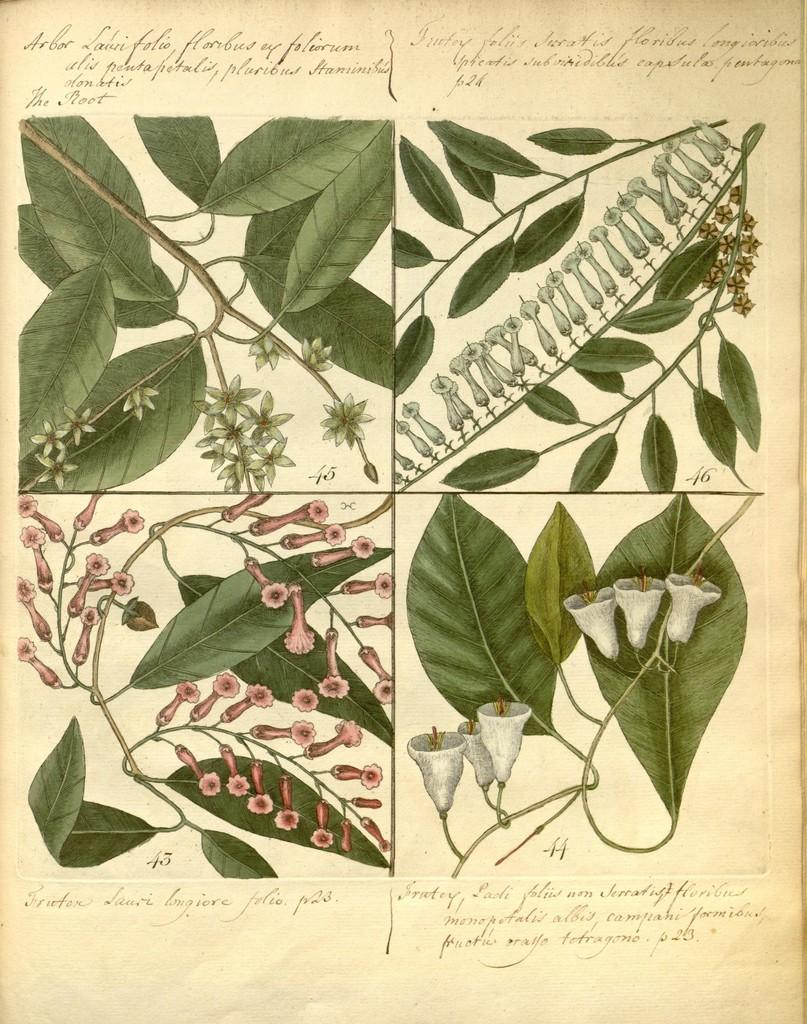What is the main subject of the poster in the image? The main subject of the poster in the image is plants. What type of thread is being used to sew the card in the image? There is no card or thread present in the image; it only features a poster of plants. 